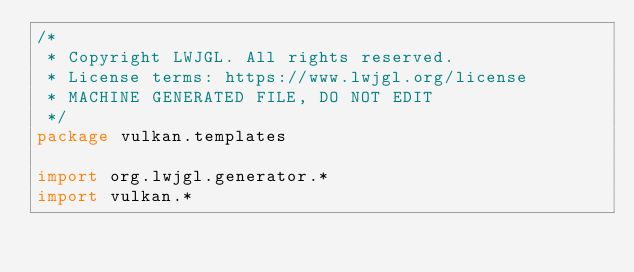Convert code to text. <code><loc_0><loc_0><loc_500><loc_500><_Kotlin_>/*
 * Copyright LWJGL. All rights reserved.
 * License terms: https://www.lwjgl.org/license
 * MACHINE GENERATED FILE, DO NOT EDIT
 */
package vulkan.templates

import org.lwjgl.generator.*
import vulkan.*
</code> 